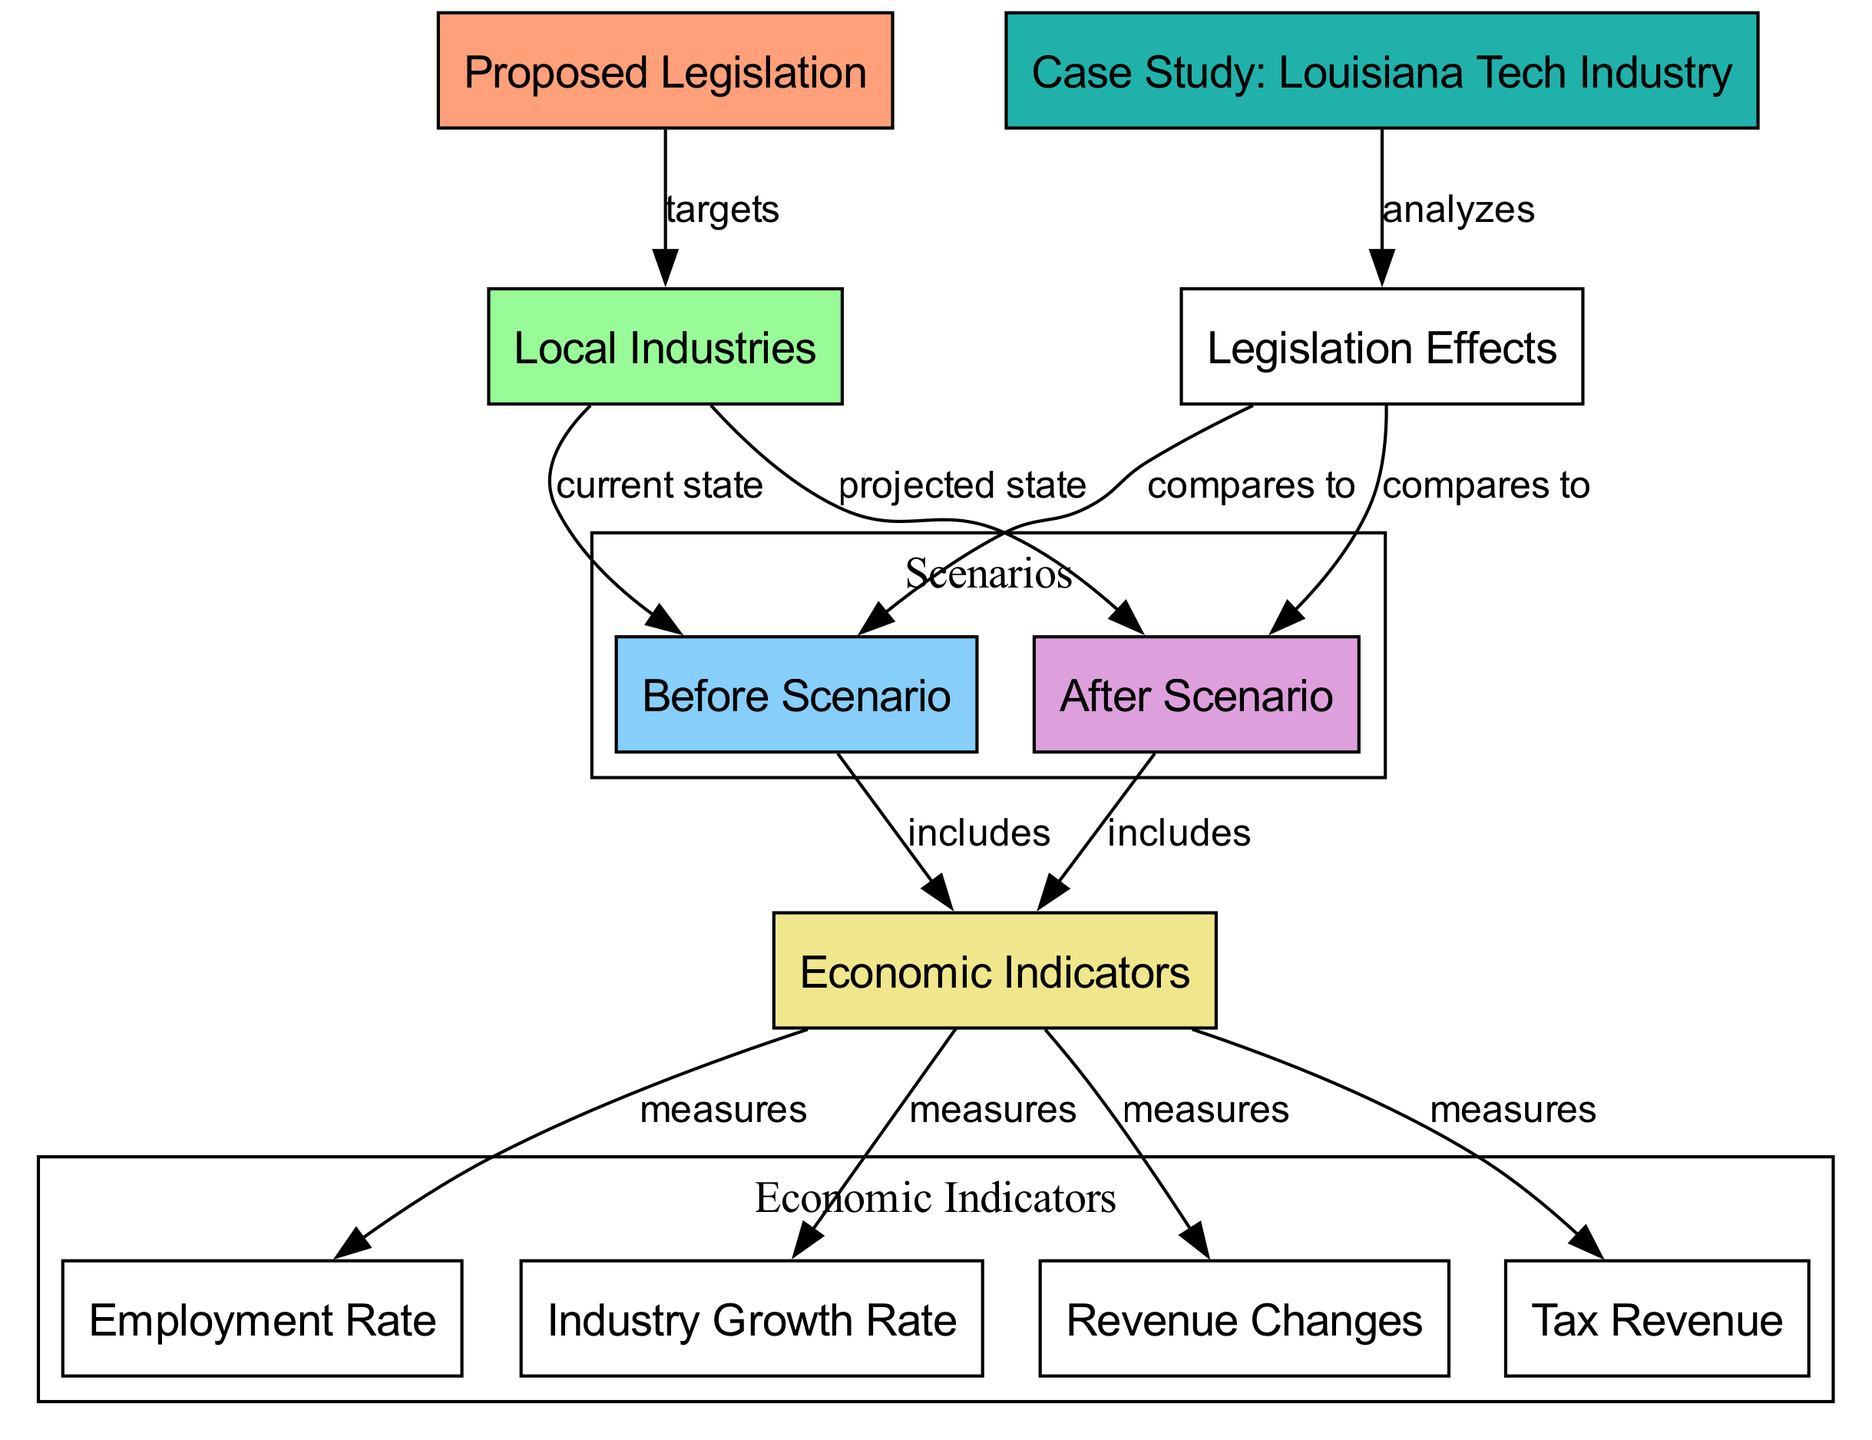What does the proposed legislation target? The proposed legislation specifically targets local industries as indicated by the relationship in the diagram where "proposed_legislation" points to "local_industries."
Answer: local industries How many economic indicators are there? The diagram indicates that there are four economic indicators measured under both before and after scenarios (employment rate, industry growth rate, revenue changes, tax revenue).
Answer: four What is compared to legislation effects? The legislation effects compare both the before scenario and the after scenario, as shown by the connections from "legislation_effects" to both "before_scenario" and "after_scenario."
Answer: before scenario and after scenario What node indicates the current state of local industries? In the diagram, the current state of local industries is represented by the node labeled "before_scenario."
Answer: before scenario Which case study analyzes legislation effects? The node labeled "case_study" specifically analyzes the effects of legislation on the local industries, as indicated by its connection to "legislation_effects."
Answer: Louisiana Tech Industry What economic indicator measures employment rate? The employment rate is listed as one of the economic indicators that measures the effects in both scenarios, connecting from "economic_indicators."
Answer: employment rate What do the before and after scenarios include? Both before and after scenarios include various economic indicators, as indicated by the arrows pointing from both to the "economic_indicators" node.
Answer: economic indicators Which node describes projected changes? The node labeled "after_scenario" describes the projected changes expected to occur due to the proposed legislation.
Answer: after scenario 